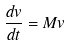<formula> <loc_0><loc_0><loc_500><loc_500>\frac { d v } { d t } = M v</formula> 